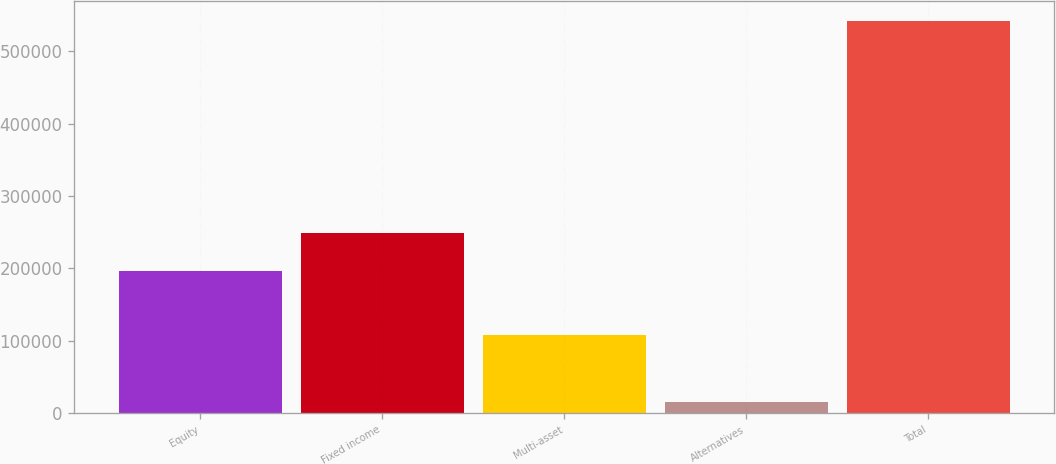Convert chart to OTSL. <chart><loc_0><loc_0><loc_500><loc_500><bar_chart><fcel>Equity<fcel>Fixed income<fcel>Multi-asset<fcel>Alternatives<fcel>Total<nl><fcel>196221<fcel>248868<fcel>107997<fcel>15478<fcel>541952<nl></chart> 